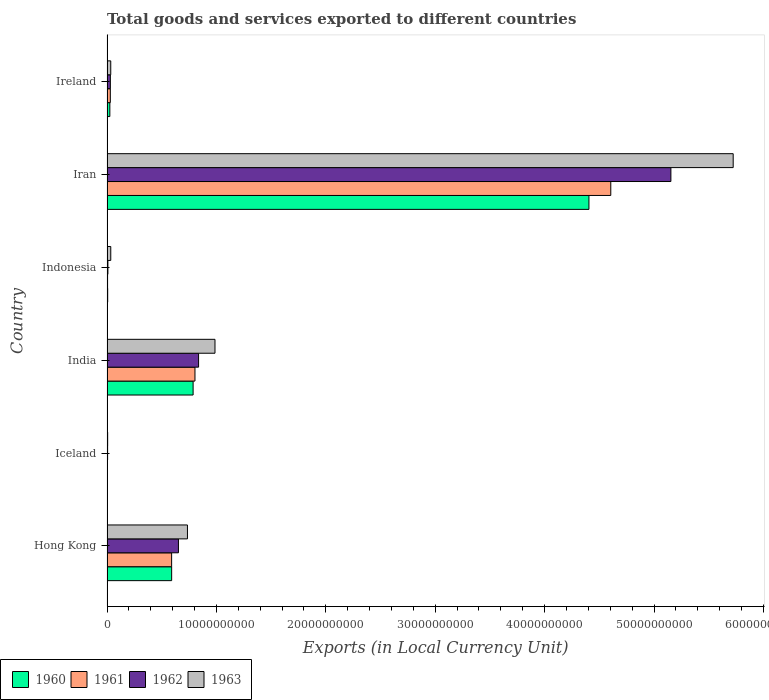How many different coloured bars are there?
Provide a short and direct response. 4. How many groups of bars are there?
Provide a short and direct response. 6. Are the number of bars per tick equal to the number of legend labels?
Your response must be concise. Yes. How many bars are there on the 1st tick from the top?
Your response must be concise. 4. How many bars are there on the 5th tick from the bottom?
Ensure brevity in your answer.  4. In how many cases, is the number of bars for a given country not equal to the number of legend labels?
Your answer should be very brief. 0. What is the Amount of goods and services exports in 1961 in Indonesia?
Make the answer very short. 5.31e+07. Across all countries, what is the maximum Amount of goods and services exports in 1960?
Your answer should be very brief. 4.41e+1. Across all countries, what is the minimum Amount of goods and services exports in 1960?
Offer a very short reply. 3.71e+07. In which country was the Amount of goods and services exports in 1961 maximum?
Your answer should be compact. Iran. In which country was the Amount of goods and services exports in 1960 minimum?
Make the answer very short. Iceland. What is the total Amount of goods and services exports in 1963 in the graph?
Make the answer very short. 7.52e+1. What is the difference between the Amount of goods and services exports in 1961 in Hong Kong and that in Iceland?
Your answer should be compact. 5.87e+09. What is the difference between the Amount of goods and services exports in 1963 in Iceland and the Amount of goods and services exports in 1960 in Indonesia?
Ensure brevity in your answer.  -1.79e+06. What is the average Amount of goods and services exports in 1961 per country?
Make the answer very short. 1.01e+1. What is the difference between the Amount of goods and services exports in 1962 and Amount of goods and services exports in 1961 in India?
Provide a short and direct response. 3.30e+08. What is the ratio of the Amount of goods and services exports in 1963 in Hong Kong to that in Ireland?
Ensure brevity in your answer.  21.44. Is the Amount of goods and services exports in 1963 in Iceland less than that in Ireland?
Keep it short and to the point. Yes. Is the difference between the Amount of goods and services exports in 1962 in Iceland and Iran greater than the difference between the Amount of goods and services exports in 1961 in Iceland and Iran?
Keep it short and to the point. No. What is the difference between the highest and the second highest Amount of goods and services exports in 1962?
Make the answer very short. 4.32e+1. What is the difference between the highest and the lowest Amount of goods and services exports in 1962?
Provide a succinct answer. 5.15e+1. In how many countries, is the Amount of goods and services exports in 1961 greater than the average Amount of goods and services exports in 1961 taken over all countries?
Ensure brevity in your answer.  1. What does the 3rd bar from the top in Ireland represents?
Make the answer very short. 1961. What does the 1st bar from the bottom in Hong Kong represents?
Offer a very short reply. 1960. Is it the case that in every country, the sum of the Amount of goods and services exports in 1961 and Amount of goods and services exports in 1960 is greater than the Amount of goods and services exports in 1962?
Your answer should be compact. Yes. How many bars are there?
Ensure brevity in your answer.  24. Are all the bars in the graph horizontal?
Offer a terse response. Yes. How many countries are there in the graph?
Make the answer very short. 6. Does the graph contain any zero values?
Make the answer very short. No. How are the legend labels stacked?
Ensure brevity in your answer.  Horizontal. What is the title of the graph?
Ensure brevity in your answer.  Total goods and services exported to different countries. Does "2012" appear as one of the legend labels in the graph?
Make the answer very short. No. What is the label or title of the X-axis?
Provide a short and direct response. Exports (in Local Currency Unit). What is the label or title of the Y-axis?
Offer a very short reply. Country. What is the Exports (in Local Currency Unit) of 1960 in Hong Kong?
Ensure brevity in your answer.  5.91e+09. What is the Exports (in Local Currency Unit) in 1961 in Hong Kong?
Provide a short and direct response. 5.91e+09. What is the Exports (in Local Currency Unit) of 1962 in Hong Kong?
Offer a very short reply. 6.53e+09. What is the Exports (in Local Currency Unit) of 1963 in Hong Kong?
Your answer should be compact. 7.35e+09. What is the Exports (in Local Currency Unit) in 1960 in Iceland?
Your answer should be very brief. 3.71e+07. What is the Exports (in Local Currency Unit) of 1961 in Iceland?
Offer a terse response. 4.21e+07. What is the Exports (in Local Currency Unit) of 1962 in Iceland?
Offer a terse response. 5.52e+07. What is the Exports (in Local Currency Unit) in 1963 in Iceland?
Your response must be concise. 6.02e+07. What is the Exports (in Local Currency Unit) of 1960 in India?
Provide a succinct answer. 7.87e+09. What is the Exports (in Local Currency Unit) of 1961 in India?
Provide a short and direct response. 8.04e+09. What is the Exports (in Local Currency Unit) of 1962 in India?
Offer a terse response. 8.37e+09. What is the Exports (in Local Currency Unit) in 1963 in India?
Your answer should be compact. 9.87e+09. What is the Exports (in Local Currency Unit) in 1960 in Indonesia?
Give a very brief answer. 6.20e+07. What is the Exports (in Local Currency Unit) in 1961 in Indonesia?
Your response must be concise. 5.31e+07. What is the Exports (in Local Currency Unit) in 1962 in Indonesia?
Keep it short and to the point. 8.19e+07. What is the Exports (in Local Currency Unit) in 1963 in Indonesia?
Give a very brief answer. 3.44e+08. What is the Exports (in Local Currency Unit) in 1960 in Iran?
Keep it short and to the point. 4.41e+1. What is the Exports (in Local Currency Unit) in 1961 in Iran?
Make the answer very short. 4.60e+1. What is the Exports (in Local Currency Unit) of 1962 in Iran?
Offer a very short reply. 5.15e+1. What is the Exports (in Local Currency Unit) of 1963 in Iran?
Provide a succinct answer. 5.72e+1. What is the Exports (in Local Currency Unit) in 1960 in Ireland?
Ensure brevity in your answer.  2.60e+08. What is the Exports (in Local Currency Unit) of 1961 in Ireland?
Give a very brief answer. 3.04e+08. What is the Exports (in Local Currency Unit) of 1962 in Ireland?
Offer a terse response. 3.07e+08. What is the Exports (in Local Currency Unit) in 1963 in Ireland?
Ensure brevity in your answer.  3.43e+08. Across all countries, what is the maximum Exports (in Local Currency Unit) in 1960?
Make the answer very short. 4.41e+1. Across all countries, what is the maximum Exports (in Local Currency Unit) in 1961?
Offer a very short reply. 4.60e+1. Across all countries, what is the maximum Exports (in Local Currency Unit) in 1962?
Your response must be concise. 5.15e+1. Across all countries, what is the maximum Exports (in Local Currency Unit) of 1963?
Give a very brief answer. 5.72e+1. Across all countries, what is the minimum Exports (in Local Currency Unit) of 1960?
Ensure brevity in your answer.  3.71e+07. Across all countries, what is the minimum Exports (in Local Currency Unit) in 1961?
Offer a terse response. 4.21e+07. Across all countries, what is the minimum Exports (in Local Currency Unit) in 1962?
Your answer should be compact. 5.52e+07. Across all countries, what is the minimum Exports (in Local Currency Unit) in 1963?
Your answer should be compact. 6.02e+07. What is the total Exports (in Local Currency Unit) of 1960 in the graph?
Provide a succinct answer. 5.82e+1. What is the total Exports (in Local Currency Unit) of 1961 in the graph?
Your response must be concise. 6.04e+1. What is the total Exports (in Local Currency Unit) in 1962 in the graph?
Make the answer very short. 6.69e+1. What is the total Exports (in Local Currency Unit) in 1963 in the graph?
Offer a terse response. 7.52e+1. What is the difference between the Exports (in Local Currency Unit) of 1960 in Hong Kong and that in Iceland?
Your answer should be compact. 5.87e+09. What is the difference between the Exports (in Local Currency Unit) in 1961 in Hong Kong and that in Iceland?
Give a very brief answer. 5.87e+09. What is the difference between the Exports (in Local Currency Unit) of 1962 in Hong Kong and that in Iceland?
Offer a terse response. 6.47e+09. What is the difference between the Exports (in Local Currency Unit) in 1963 in Hong Kong and that in Iceland?
Offer a terse response. 7.29e+09. What is the difference between the Exports (in Local Currency Unit) of 1960 in Hong Kong and that in India?
Your response must be concise. -1.96e+09. What is the difference between the Exports (in Local Currency Unit) of 1961 in Hong Kong and that in India?
Ensure brevity in your answer.  -2.13e+09. What is the difference between the Exports (in Local Currency Unit) in 1962 in Hong Kong and that in India?
Offer a terse response. -1.84e+09. What is the difference between the Exports (in Local Currency Unit) in 1963 in Hong Kong and that in India?
Offer a terse response. -2.52e+09. What is the difference between the Exports (in Local Currency Unit) in 1960 in Hong Kong and that in Indonesia?
Your answer should be very brief. 5.85e+09. What is the difference between the Exports (in Local Currency Unit) in 1961 in Hong Kong and that in Indonesia?
Your answer should be very brief. 5.85e+09. What is the difference between the Exports (in Local Currency Unit) in 1962 in Hong Kong and that in Indonesia?
Keep it short and to the point. 6.45e+09. What is the difference between the Exports (in Local Currency Unit) in 1963 in Hong Kong and that in Indonesia?
Keep it short and to the point. 7.01e+09. What is the difference between the Exports (in Local Currency Unit) in 1960 in Hong Kong and that in Iran?
Your answer should be compact. -3.81e+1. What is the difference between the Exports (in Local Currency Unit) in 1961 in Hong Kong and that in Iran?
Offer a terse response. -4.01e+1. What is the difference between the Exports (in Local Currency Unit) of 1962 in Hong Kong and that in Iran?
Provide a succinct answer. -4.50e+1. What is the difference between the Exports (in Local Currency Unit) in 1963 in Hong Kong and that in Iran?
Your answer should be very brief. -4.99e+1. What is the difference between the Exports (in Local Currency Unit) in 1960 in Hong Kong and that in Ireland?
Provide a succinct answer. 5.65e+09. What is the difference between the Exports (in Local Currency Unit) in 1961 in Hong Kong and that in Ireland?
Offer a terse response. 5.60e+09. What is the difference between the Exports (in Local Currency Unit) of 1962 in Hong Kong and that in Ireland?
Your response must be concise. 6.22e+09. What is the difference between the Exports (in Local Currency Unit) of 1963 in Hong Kong and that in Ireland?
Your response must be concise. 7.01e+09. What is the difference between the Exports (in Local Currency Unit) in 1960 in Iceland and that in India?
Ensure brevity in your answer.  -7.83e+09. What is the difference between the Exports (in Local Currency Unit) of 1961 in Iceland and that in India?
Offer a very short reply. -8.00e+09. What is the difference between the Exports (in Local Currency Unit) in 1962 in Iceland and that in India?
Ensure brevity in your answer.  -8.31e+09. What is the difference between the Exports (in Local Currency Unit) in 1963 in Iceland and that in India?
Ensure brevity in your answer.  -9.81e+09. What is the difference between the Exports (in Local Currency Unit) in 1960 in Iceland and that in Indonesia?
Your answer should be very brief. -2.49e+07. What is the difference between the Exports (in Local Currency Unit) in 1961 in Iceland and that in Indonesia?
Ensure brevity in your answer.  -1.10e+07. What is the difference between the Exports (in Local Currency Unit) in 1962 in Iceland and that in Indonesia?
Provide a succinct answer. -2.67e+07. What is the difference between the Exports (in Local Currency Unit) in 1963 in Iceland and that in Indonesia?
Provide a succinct answer. -2.84e+08. What is the difference between the Exports (in Local Currency Unit) of 1960 in Iceland and that in Iran?
Give a very brief answer. -4.40e+1. What is the difference between the Exports (in Local Currency Unit) of 1961 in Iceland and that in Iran?
Keep it short and to the point. -4.60e+1. What is the difference between the Exports (in Local Currency Unit) in 1962 in Iceland and that in Iran?
Offer a terse response. -5.15e+1. What is the difference between the Exports (in Local Currency Unit) of 1963 in Iceland and that in Iran?
Offer a terse response. -5.72e+1. What is the difference between the Exports (in Local Currency Unit) in 1960 in Iceland and that in Ireland?
Give a very brief answer. -2.23e+08. What is the difference between the Exports (in Local Currency Unit) in 1961 in Iceland and that in Ireland?
Ensure brevity in your answer.  -2.62e+08. What is the difference between the Exports (in Local Currency Unit) in 1962 in Iceland and that in Ireland?
Give a very brief answer. -2.51e+08. What is the difference between the Exports (in Local Currency Unit) in 1963 in Iceland and that in Ireland?
Your answer should be compact. -2.83e+08. What is the difference between the Exports (in Local Currency Unit) of 1960 in India and that in Indonesia?
Provide a short and direct response. 7.81e+09. What is the difference between the Exports (in Local Currency Unit) in 1961 in India and that in Indonesia?
Provide a short and direct response. 7.99e+09. What is the difference between the Exports (in Local Currency Unit) in 1962 in India and that in Indonesia?
Your answer should be compact. 8.29e+09. What is the difference between the Exports (in Local Currency Unit) in 1963 in India and that in Indonesia?
Offer a very short reply. 9.53e+09. What is the difference between the Exports (in Local Currency Unit) of 1960 in India and that in Iran?
Keep it short and to the point. -3.62e+1. What is the difference between the Exports (in Local Currency Unit) in 1961 in India and that in Iran?
Ensure brevity in your answer.  -3.80e+1. What is the difference between the Exports (in Local Currency Unit) in 1962 in India and that in Iran?
Provide a short and direct response. -4.32e+1. What is the difference between the Exports (in Local Currency Unit) in 1963 in India and that in Iran?
Your response must be concise. -4.74e+1. What is the difference between the Exports (in Local Currency Unit) of 1960 in India and that in Ireland?
Ensure brevity in your answer.  7.61e+09. What is the difference between the Exports (in Local Currency Unit) of 1961 in India and that in Ireland?
Your response must be concise. 7.74e+09. What is the difference between the Exports (in Local Currency Unit) of 1962 in India and that in Ireland?
Ensure brevity in your answer.  8.06e+09. What is the difference between the Exports (in Local Currency Unit) of 1963 in India and that in Ireland?
Your answer should be very brief. 9.53e+09. What is the difference between the Exports (in Local Currency Unit) in 1960 in Indonesia and that in Iran?
Provide a succinct answer. -4.40e+1. What is the difference between the Exports (in Local Currency Unit) in 1961 in Indonesia and that in Iran?
Your answer should be very brief. -4.60e+1. What is the difference between the Exports (in Local Currency Unit) in 1962 in Indonesia and that in Iran?
Offer a terse response. -5.15e+1. What is the difference between the Exports (in Local Currency Unit) in 1963 in Indonesia and that in Iran?
Provide a short and direct response. -5.69e+1. What is the difference between the Exports (in Local Currency Unit) in 1960 in Indonesia and that in Ireland?
Your answer should be compact. -1.98e+08. What is the difference between the Exports (in Local Currency Unit) of 1961 in Indonesia and that in Ireland?
Offer a very short reply. -2.51e+08. What is the difference between the Exports (in Local Currency Unit) of 1962 in Indonesia and that in Ireland?
Offer a terse response. -2.25e+08. What is the difference between the Exports (in Local Currency Unit) in 1963 in Indonesia and that in Ireland?
Offer a terse response. 1.22e+06. What is the difference between the Exports (in Local Currency Unit) of 1960 in Iran and that in Ireland?
Your answer should be compact. 4.38e+1. What is the difference between the Exports (in Local Currency Unit) in 1961 in Iran and that in Ireland?
Keep it short and to the point. 4.57e+1. What is the difference between the Exports (in Local Currency Unit) in 1962 in Iran and that in Ireland?
Make the answer very short. 5.12e+1. What is the difference between the Exports (in Local Currency Unit) in 1963 in Iran and that in Ireland?
Offer a very short reply. 5.69e+1. What is the difference between the Exports (in Local Currency Unit) of 1960 in Hong Kong and the Exports (in Local Currency Unit) of 1961 in Iceland?
Provide a short and direct response. 5.87e+09. What is the difference between the Exports (in Local Currency Unit) in 1960 in Hong Kong and the Exports (in Local Currency Unit) in 1962 in Iceland?
Give a very brief answer. 5.85e+09. What is the difference between the Exports (in Local Currency Unit) in 1960 in Hong Kong and the Exports (in Local Currency Unit) in 1963 in Iceland?
Offer a terse response. 5.85e+09. What is the difference between the Exports (in Local Currency Unit) of 1961 in Hong Kong and the Exports (in Local Currency Unit) of 1962 in Iceland?
Provide a succinct answer. 5.85e+09. What is the difference between the Exports (in Local Currency Unit) of 1961 in Hong Kong and the Exports (in Local Currency Unit) of 1963 in Iceland?
Your answer should be very brief. 5.85e+09. What is the difference between the Exports (in Local Currency Unit) of 1962 in Hong Kong and the Exports (in Local Currency Unit) of 1963 in Iceland?
Your response must be concise. 6.47e+09. What is the difference between the Exports (in Local Currency Unit) of 1960 in Hong Kong and the Exports (in Local Currency Unit) of 1961 in India?
Your answer should be compact. -2.13e+09. What is the difference between the Exports (in Local Currency Unit) in 1960 in Hong Kong and the Exports (in Local Currency Unit) in 1962 in India?
Offer a very short reply. -2.46e+09. What is the difference between the Exports (in Local Currency Unit) in 1960 in Hong Kong and the Exports (in Local Currency Unit) in 1963 in India?
Your answer should be very brief. -3.96e+09. What is the difference between the Exports (in Local Currency Unit) of 1961 in Hong Kong and the Exports (in Local Currency Unit) of 1962 in India?
Offer a terse response. -2.46e+09. What is the difference between the Exports (in Local Currency Unit) in 1961 in Hong Kong and the Exports (in Local Currency Unit) in 1963 in India?
Provide a succinct answer. -3.96e+09. What is the difference between the Exports (in Local Currency Unit) of 1962 in Hong Kong and the Exports (in Local Currency Unit) of 1963 in India?
Provide a succinct answer. -3.34e+09. What is the difference between the Exports (in Local Currency Unit) in 1960 in Hong Kong and the Exports (in Local Currency Unit) in 1961 in Indonesia?
Offer a terse response. 5.86e+09. What is the difference between the Exports (in Local Currency Unit) in 1960 in Hong Kong and the Exports (in Local Currency Unit) in 1962 in Indonesia?
Offer a terse response. 5.83e+09. What is the difference between the Exports (in Local Currency Unit) in 1960 in Hong Kong and the Exports (in Local Currency Unit) in 1963 in Indonesia?
Your answer should be very brief. 5.57e+09. What is the difference between the Exports (in Local Currency Unit) of 1961 in Hong Kong and the Exports (in Local Currency Unit) of 1962 in Indonesia?
Offer a very short reply. 5.83e+09. What is the difference between the Exports (in Local Currency Unit) in 1961 in Hong Kong and the Exports (in Local Currency Unit) in 1963 in Indonesia?
Provide a succinct answer. 5.56e+09. What is the difference between the Exports (in Local Currency Unit) of 1962 in Hong Kong and the Exports (in Local Currency Unit) of 1963 in Indonesia?
Give a very brief answer. 6.19e+09. What is the difference between the Exports (in Local Currency Unit) of 1960 in Hong Kong and the Exports (in Local Currency Unit) of 1961 in Iran?
Your answer should be compact. -4.01e+1. What is the difference between the Exports (in Local Currency Unit) of 1960 in Hong Kong and the Exports (in Local Currency Unit) of 1962 in Iran?
Your answer should be very brief. -4.56e+1. What is the difference between the Exports (in Local Currency Unit) of 1960 in Hong Kong and the Exports (in Local Currency Unit) of 1963 in Iran?
Make the answer very short. -5.13e+1. What is the difference between the Exports (in Local Currency Unit) of 1961 in Hong Kong and the Exports (in Local Currency Unit) of 1962 in Iran?
Provide a succinct answer. -4.56e+1. What is the difference between the Exports (in Local Currency Unit) of 1961 in Hong Kong and the Exports (in Local Currency Unit) of 1963 in Iran?
Your response must be concise. -5.13e+1. What is the difference between the Exports (in Local Currency Unit) in 1962 in Hong Kong and the Exports (in Local Currency Unit) in 1963 in Iran?
Offer a terse response. -5.07e+1. What is the difference between the Exports (in Local Currency Unit) in 1960 in Hong Kong and the Exports (in Local Currency Unit) in 1961 in Ireland?
Give a very brief answer. 5.61e+09. What is the difference between the Exports (in Local Currency Unit) in 1960 in Hong Kong and the Exports (in Local Currency Unit) in 1962 in Ireland?
Provide a succinct answer. 5.60e+09. What is the difference between the Exports (in Local Currency Unit) in 1960 in Hong Kong and the Exports (in Local Currency Unit) in 1963 in Ireland?
Keep it short and to the point. 5.57e+09. What is the difference between the Exports (in Local Currency Unit) in 1961 in Hong Kong and the Exports (in Local Currency Unit) in 1962 in Ireland?
Provide a short and direct response. 5.60e+09. What is the difference between the Exports (in Local Currency Unit) in 1961 in Hong Kong and the Exports (in Local Currency Unit) in 1963 in Ireland?
Provide a succinct answer. 5.56e+09. What is the difference between the Exports (in Local Currency Unit) in 1962 in Hong Kong and the Exports (in Local Currency Unit) in 1963 in Ireland?
Offer a terse response. 6.19e+09. What is the difference between the Exports (in Local Currency Unit) in 1960 in Iceland and the Exports (in Local Currency Unit) in 1961 in India?
Give a very brief answer. -8.00e+09. What is the difference between the Exports (in Local Currency Unit) of 1960 in Iceland and the Exports (in Local Currency Unit) of 1962 in India?
Provide a succinct answer. -8.33e+09. What is the difference between the Exports (in Local Currency Unit) of 1960 in Iceland and the Exports (in Local Currency Unit) of 1963 in India?
Give a very brief answer. -9.83e+09. What is the difference between the Exports (in Local Currency Unit) in 1961 in Iceland and the Exports (in Local Currency Unit) in 1962 in India?
Keep it short and to the point. -8.33e+09. What is the difference between the Exports (in Local Currency Unit) of 1961 in Iceland and the Exports (in Local Currency Unit) of 1963 in India?
Provide a succinct answer. -9.83e+09. What is the difference between the Exports (in Local Currency Unit) of 1962 in Iceland and the Exports (in Local Currency Unit) of 1963 in India?
Give a very brief answer. -9.81e+09. What is the difference between the Exports (in Local Currency Unit) in 1960 in Iceland and the Exports (in Local Currency Unit) in 1961 in Indonesia?
Your answer should be very brief. -1.60e+07. What is the difference between the Exports (in Local Currency Unit) of 1960 in Iceland and the Exports (in Local Currency Unit) of 1962 in Indonesia?
Provide a succinct answer. -4.48e+07. What is the difference between the Exports (in Local Currency Unit) in 1960 in Iceland and the Exports (in Local Currency Unit) in 1963 in Indonesia?
Your answer should be compact. -3.07e+08. What is the difference between the Exports (in Local Currency Unit) of 1961 in Iceland and the Exports (in Local Currency Unit) of 1962 in Indonesia?
Your response must be concise. -3.98e+07. What is the difference between the Exports (in Local Currency Unit) of 1961 in Iceland and the Exports (in Local Currency Unit) of 1963 in Indonesia?
Your answer should be very brief. -3.02e+08. What is the difference between the Exports (in Local Currency Unit) in 1962 in Iceland and the Exports (in Local Currency Unit) in 1963 in Indonesia?
Your answer should be very brief. -2.89e+08. What is the difference between the Exports (in Local Currency Unit) in 1960 in Iceland and the Exports (in Local Currency Unit) in 1961 in Iran?
Provide a succinct answer. -4.60e+1. What is the difference between the Exports (in Local Currency Unit) in 1960 in Iceland and the Exports (in Local Currency Unit) in 1962 in Iran?
Ensure brevity in your answer.  -5.15e+1. What is the difference between the Exports (in Local Currency Unit) of 1960 in Iceland and the Exports (in Local Currency Unit) of 1963 in Iran?
Offer a terse response. -5.72e+1. What is the difference between the Exports (in Local Currency Unit) of 1961 in Iceland and the Exports (in Local Currency Unit) of 1962 in Iran?
Offer a very short reply. -5.15e+1. What is the difference between the Exports (in Local Currency Unit) in 1961 in Iceland and the Exports (in Local Currency Unit) in 1963 in Iran?
Offer a terse response. -5.72e+1. What is the difference between the Exports (in Local Currency Unit) in 1962 in Iceland and the Exports (in Local Currency Unit) in 1963 in Iran?
Offer a terse response. -5.72e+1. What is the difference between the Exports (in Local Currency Unit) of 1960 in Iceland and the Exports (in Local Currency Unit) of 1961 in Ireland?
Provide a short and direct response. -2.67e+08. What is the difference between the Exports (in Local Currency Unit) in 1960 in Iceland and the Exports (in Local Currency Unit) in 1962 in Ireland?
Offer a very short reply. -2.69e+08. What is the difference between the Exports (in Local Currency Unit) in 1960 in Iceland and the Exports (in Local Currency Unit) in 1963 in Ireland?
Ensure brevity in your answer.  -3.06e+08. What is the difference between the Exports (in Local Currency Unit) of 1961 in Iceland and the Exports (in Local Currency Unit) of 1962 in Ireland?
Offer a terse response. -2.64e+08. What is the difference between the Exports (in Local Currency Unit) in 1961 in Iceland and the Exports (in Local Currency Unit) in 1963 in Ireland?
Provide a succinct answer. -3.01e+08. What is the difference between the Exports (in Local Currency Unit) of 1962 in Iceland and the Exports (in Local Currency Unit) of 1963 in Ireland?
Your answer should be very brief. -2.88e+08. What is the difference between the Exports (in Local Currency Unit) in 1960 in India and the Exports (in Local Currency Unit) in 1961 in Indonesia?
Offer a terse response. 7.82e+09. What is the difference between the Exports (in Local Currency Unit) in 1960 in India and the Exports (in Local Currency Unit) in 1962 in Indonesia?
Offer a terse response. 7.79e+09. What is the difference between the Exports (in Local Currency Unit) in 1960 in India and the Exports (in Local Currency Unit) in 1963 in Indonesia?
Offer a terse response. 7.53e+09. What is the difference between the Exports (in Local Currency Unit) in 1961 in India and the Exports (in Local Currency Unit) in 1962 in Indonesia?
Keep it short and to the point. 7.96e+09. What is the difference between the Exports (in Local Currency Unit) in 1961 in India and the Exports (in Local Currency Unit) in 1963 in Indonesia?
Your response must be concise. 7.70e+09. What is the difference between the Exports (in Local Currency Unit) in 1962 in India and the Exports (in Local Currency Unit) in 1963 in Indonesia?
Provide a short and direct response. 8.03e+09. What is the difference between the Exports (in Local Currency Unit) of 1960 in India and the Exports (in Local Currency Unit) of 1961 in Iran?
Make the answer very short. -3.82e+1. What is the difference between the Exports (in Local Currency Unit) of 1960 in India and the Exports (in Local Currency Unit) of 1962 in Iran?
Ensure brevity in your answer.  -4.37e+1. What is the difference between the Exports (in Local Currency Unit) of 1960 in India and the Exports (in Local Currency Unit) of 1963 in Iran?
Provide a short and direct response. -4.94e+1. What is the difference between the Exports (in Local Currency Unit) of 1961 in India and the Exports (in Local Currency Unit) of 1962 in Iran?
Your answer should be compact. -4.35e+1. What is the difference between the Exports (in Local Currency Unit) in 1961 in India and the Exports (in Local Currency Unit) in 1963 in Iran?
Give a very brief answer. -4.92e+1. What is the difference between the Exports (in Local Currency Unit) of 1962 in India and the Exports (in Local Currency Unit) of 1963 in Iran?
Offer a terse response. -4.89e+1. What is the difference between the Exports (in Local Currency Unit) in 1960 in India and the Exports (in Local Currency Unit) in 1961 in Ireland?
Keep it short and to the point. 7.57e+09. What is the difference between the Exports (in Local Currency Unit) of 1960 in India and the Exports (in Local Currency Unit) of 1962 in Ireland?
Keep it short and to the point. 7.56e+09. What is the difference between the Exports (in Local Currency Unit) of 1960 in India and the Exports (in Local Currency Unit) of 1963 in Ireland?
Give a very brief answer. 7.53e+09. What is the difference between the Exports (in Local Currency Unit) of 1961 in India and the Exports (in Local Currency Unit) of 1962 in Ireland?
Provide a succinct answer. 7.73e+09. What is the difference between the Exports (in Local Currency Unit) in 1961 in India and the Exports (in Local Currency Unit) in 1963 in Ireland?
Your answer should be compact. 7.70e+09. What is the difference between the Exports (in Local Currency Unit) of 1962 in India and the Exports (in Local Currency Unit) of 1963 in Ireland?
Provide a short and direct response. 8.03e+09. What is the difference between the Exports (in Local Currency Unit) in 1960 in Indonesia and the Exports (in Local Currency Unit) in 1961 in Iran?
Offer a very short reply. -4.60e+1. What is the difference between the Exports (in Local Currency Unit) of 1960 in Indonesia and the Exports (in Local Currency Unit) of 1962 in Iran?
Make the answer very short. -5.15e+1. What is the difference between the Exports (in Local Currency Unit) of 1960 in Indonesia and the Exports (in Local Currency Unit) of 1963 in Iran?
Your response must be concise. -5.72e+1. What is the difference between the Exports (in Local Currency Unit) in 1961 in Indonesia and the Exports (in Local Currency Unit) in 1962 in Iran?
Give a very brief answer. -5.15e+1. What is the difference between the Exports (in Local Currency Unit) in 1961 in Indonesia and the Exports (in Local Currency Unit) in 1963 in Iran?
Your answer should be compact. -5.72e+1. What is the difference between the Exports (in Local Currency Unit) in 1962 in Indonesia and the Exports (in Local Currency Unit) in 1963 in Iran?
Your response must be concise. -5.72e+1. What is the difference between the Exports (in Local Currency Unit) in 1960 in Indonesia and the Exports (in Local Currency Unit) in 1961 in Ireland?
Your answer should be compact. -2.42e+08. What is the difference between the Exports (in Local Currency Unit) of 1960 in Indonesia and the Exports (in Local Currency Unit) of 1962 in Ireland?
Make the answer very short. -2.45e+08. What is the difference between the Exports (in Local Currency Unit) of 1960 in Indonesia and the Exports (in Local Currency Unit) of 1963 in Ireland?
Your response must be concise. -2.81e+08. What is the difference between the Exports (in Local Currency Unit) in 1961 in Indonesia and the Exports (in Local Currency Unit) in 1962 in Ireland?
Provide a short and direct response. -2.53e+08. What is the difference between the Exports (in Local Currency Unit) of 1961 in Indonesia and the Exports (in Local Currency Unit) of 1963 in Ireland?
Make the answer very short. -2.90e+08. What is the difference between the Exports (in Local Currency Unit) of 1962 in Indonesia and the Exports (in Local Currency Unit) of 1963 in Ireland?
Keep it short and to the point. -2.61e+08. What is the difference between the Exports (in Local Currency Unit) in 1960 in Iran and the Exports (in Local Currency Unit) in 1961 in Ireland?
Your response must be concise. 4.37e+1. What is the difference between the Exports (in Local Currency Unit) of 1960 in Iran and the Exports (in Local Currency Unit) of 1962 in Ireland?
Offer a very short reply. 4.37e+1. What is the difference between the Exports (in Local Currency Unit) in 1960 in Iran and the Exports (in Local Currency Unit) in 1963 in Ireland?
Make the answer very short. 4.37e+1. What is the difference between the Exports (in Local Currency Unit) in 1961 in Iran and the Exports (in Local Currency Unit) in 1962 in Ireland?
Offer a very short reply. 4.57e+1. What is the difference between the Exports (in Local Currency Unit) in 1961 in Iran and the Exports (in Local Currency Unit) in 1963 in Ireland?
Keep it short and to the point. 4.57e+1. What is the difference between the Exports (in Local Currency Unit) of 1962 in Iran and the Exports (in Local Currency Unit) of 1963 in Ireland?
Offer a very short reply. 5.12e+1. What is the average Exports (in Local Currency Unit) in 1960 per country?
Offer a terse response. 9.70e+09. What is the average Exports (in Local Currency Unit) of 1961 per country?
Provide a succinct answer. 1.01e+1. What is the average Exports (in Local Currency Unit) of 1962 per country?
Ensure brevity in your answer.  1.11e+1. What is the average Exports (in Local Currency Unit) in 1963 per country?
Provide a succinct answer. 1.25e+1. What is the difference between the Exports (in Local Currency Unit) in 1960 and Exports (in Local Currency Unit) in 1961 in Hong Kong?
Offer a very short reply. 2.67e+06. What is the difference between the Exports (in Local Currency Unit) in 1960 and Exports (in Local Currency Unit) in 1962 in Hong Kong?
Your response must be concise. -6.20e+08. What is the difference between the Exports (in Local Currency Unit) of 1960 and Exports (in Local Currency Unit) of 1963 in Hong Kong?
Your response must be concise. -1.44e+09. What is the difference between the Exports (in Local Currency Unit) in 1961 and Exports (in Local Currency Unit) in 1962 in Hong Kong?
Offer a terse response. -6.23e+08. What is the difference between the Exports (in Local Currency Unit) of 1961 and Exports (in Local Currency Unit) of 1963 in Hong Kong?
Your answer should be compact. -1.45e+09. What is the difference between the Exports (in Local Currency Unit) of 1962 and Exports (in Local Currency Unit) of 1963 in Hong Kong?
Give a very brief answer. -8.24e+08. What is the difference between the Exports (in Local Currency Unit) of 1960 and Exports (in Local Currency Unit) of 1961 in Iceland?
Offer a terse response. -5.02e+06. What is the difference between the Exports (in Local Currency Unit) of 1960 and Exports (in Local Currency Unit) of 1962 in Iceland?
Keep it short and to the point. -1.81e+07. What is the difference between the Exports (in Local Currency Unit) of 1960 and Exports (in Local Currency Unit) of 1963 in Iceland?
Offer a terse response. -2.31e+07. What is the difference between the Exports (in Local Currency Unit) of 1961 and Exports (in Local Currency Unit) of 1962 in Iceland?
Make the answer very short. -1.30e+07. What is the difference between the Exports (in Local Currency Unit) of 1961 and Exports (in Local Currency Unit) of 1963 in Iceland?
Provide a succinct answer. -1.81e+07. What is the difference between the Exports (in Local Currency Unit) in 1962 and Exports (in Local Currency Unit) in 1963 in Iceland?
Provide a succinct answer. -5.02e+06. What is the difference between the Exports (in Local Currency Unit) in 1960 and Exports (in Local Currency Unit) in 1961 in India?
Give a very brief answer. -1.70e+08. What is the difference between the Exports (in Local Currency Unit) of 1960 and Exports (in Local Currency Unit) of 1962 in India?
Give a very brief answer. -5.00e+08. What is the difference between the Exports (in Local Currency Unit) in 1960 and Exports (in Local Currency Unit) in 1963 in India?
Ensure brevity in your answer.  -2.00e+09. What is the difference between the Exports (in Local Currency Unit) in 1961 and Exports (in Local Currency Unit) in 1962 in India?
Offer a very short reply. -3.30e+08. What is the difference between the Exports (in Local Currency Unit) of 1961 and Exports (in Local Currency Unit) of 1963 in India?
Offer a very short reply. -1.83e+09. What is the difference between the Exports (in Local Currency Unit) of 1962 and Exports (in Local Currency Unit) of 1963 in India?
Your answer should be very brief. -1.50e+09. What is the difference between the Exports (in Local Currency Unit) in 1960 and Exports (in Local Currency Unit) in 1961 in Indonesia?
Your answer should be compact. 8.85e+06. What is the difference between the Exports (in Local Currency Unit) in 1960 and Exports (in Local Currency Unit) in 1962 in Indonesia?
Offer a terse response. -1.99e+07. What is the difference between the Exports (in Local Currency Unit) in 1960 and Exports (in Local Currency Unit) in 1963 in Indonesia?
Your answer should be very brief. -2.82e+08. What is the difference between the Exports (in Local Currency Unit) of 1961 and Exports (in Local Currency Unit) of 1962 in Indonesia?
Your answer should be compact. -2.88e+07. What is the difference between the Exports (in Local Currency Unit) of 1961 and Exports (in Local Currency Unit) of 1963 in Indonesia?
Provide a short and direct response. -2.91e+08. What is the difference between the Exports (in Local Currency Unit) in 1962 and Exports (in Local Currency Unit) in 1963 in Indonesia?
Ensure brevity in your answer.  -2.62e+08. What is the difference between the Exports (in Local Currency Unit) of 1960 and Exports (in Local Currency Unit) of 1961 in Iran?
Provide a succinct answer. -2.00e+09. What is the difference between the Exports (in Local Currency Unit) in 1960 and Exports (in Local Currency Unit) in 1962 in Iran?
Your response must be concise. -7.49e+09. What is the difference between the Exports (in Local Currency Unit) in 1960 and Exports (in Local Currency Unit) in 1963 in Iran?
Ensure brevity in your answer.  -1.32e+1. What is the difference between the Exports (in Local Currency Unit) of 1961 and Exports (in Local Currency Unit) of 1962 in Iran?
Ensure brevity in your answer.  -5.49e+09. What is the difference between the Exports (in Local Currency Unit) in 1961 and Exports (in Local Currency Unit) in 1963 in Iran?
Give a very brief answer. -1.12e+1. What is the difference between the Exports (in Local Currency Unit) in 1962 and Exports (in Local Currency Unit) in 1963 in Iran?
Your response must be concise. -5.69e+09. What is the difference between the Exports (in Local Currency Unit) in 1960 and Exports (in Local Currency Unit) in 1961 in Ireland?
Offer a very short reply. -4.43e+07. What is the difference between the Exports (in Local Currency Unit) in 1960 and Exports (in Local Currency Unit) in 1962 in Ireland?
Offer a very short reply. -4.69e+07. What is the difference between the Exports (in Local Currency Unit) of 1960 and Exports (in Local Currency Unit) of 1963 in Ireland?
Your response must be concise. -8.33e+07. What is the difference between the Exports (in Local Currency Unit) in 1961 and Exports (in Local Currency Unit) in 1962 in Ireland?
Keep it short and to the point. -2.58e+06. What is the difference between the Exports (in Local Currency Unit) of 1961 and Exports (in Local Currency Unit) of 1963 in Ireland?
Your answer should be very brief. -3.90e+07. What is the difference between the Exports (in Local Currency Unit) of 1962 and Exports (in Local Currency Unit) of 1963 in Ireland?
Keep it short and to the point. -3.64e+07. What is the ratio of the Exports (in Local Currency Unit) in 1960 in Hong Kong to that in Iceland?
Your response must be concise. 159.23. What is the ratio of the Exports (in Local Currency Unit) in 1961 in Hong Kong to that in Iceland?
Ensure brevity in your answer.  140.21. What is the ratio of the Exports (in Local Currency Unit) of 1962 in Hong Kong to that in Iceland?
Offer a terse response. 118.35. What is the ratio of the Exports (in Local Currency Unit) in 1963 in Hong Kong to that in Iceland?
Your answer should be compact. 122.18. What is the ratio of the Exports (in Local Currency Unit) in 1960 in Hong Kong to that in India?
Your response must be concise. 0.75. What is the ratio of the Exports (in Local Currency Unit) of 1961 in Hong Kong to that in India?
Make the answer very short. 0.73. What is the ratio of the Exports (in Local Currency Unit) of 1962 in Hong Kong to that in India?
Provide a succinct answer. 0.78. What is the ratio of the Exports (in Local Currency Unit) in 1963 in Hong Kong to that in India?
Your answer should be compact. 0.75. What is the ratio of the Exports (in Local Currency Unit) in 1960 in Hong Kong to that in Indonesia?
Your answer should be compact. 95.35. What is the ratio of the Exports (in Local Currency Unit) in 1961 in Hong Kong to that in Indonesia?
Offer a terse response. 111.19. What is the ratio of the Exports (in Local Currency Unit) of 1962 in Hong Kong to that in Indonesia?
Provide a succinct answer. 79.73. What is the ratio of the Exports (in Local Currency Unit) in 1963 in Hong Kong to that in Indonesia?
Offer a terse response. 21.36. What is the ratio of the Exports (in Local Currency Unit) in 1960 in Hong Kong to that in Iran?
Give a very brief answer. 0.13. What is the ratio of the Exports (in Local Currency Unit) of 1961 in Hong Kong to that in Iran?
Keep it short and to the point. 0.13. What is the ratio of the Exports (in Local Currency Unit) of 1962 in Hong Kong to that in Iran?
Offer a very short reply. 0.13. What is the ratio of the Exports (in Local Currency Unit) of 1963 in Hong Kong to that in Iran?
Your answer should be very brief. 0.13. What is the ratio of the Exports (in Local Currency Unit) in 1960 in Hong Kong to that in Ireland?
Ensure brevity in your answer.  22.76. What is the ratio of the Exports (in Local Currency Unit) in 1961 in Hong Kong to that in Ireland?
Offer a very short reply. 19.43. What is the ratio of the Exports (in Local Currency Unit) in 1962 in Hong Kong to that in Ireland?
Provide a short and direct response. 21.3. What is the ratio of the Exports (in Local Currency Unit) of 1963 in Hong Kong to that in Ireland?
Provide a succinct answer. 21.44. What is the ratio of the Exports (in Local Currency Unit) of 1960 in Iceland to that in India?
Provide a short and direct response. 0. What is the ratio of the Exports (in Local Currency Unit) in 1961 in Iceland to that in India?
Make the answer very short. 0.01. What is the ratio of the Exports (in Local Currency Unit) of 1962 in Iceland to that in India?
Keep it short and to the point. 0.01. What is the ratio of the Exports (in Local Currency Unit) of 1963 in Iceland to that in India?
Give a very brief answer. 0.01. What is the ratio of the Exports (in Local Currency Unit) in 1960 in Iceland to that in Indonesia?
Provide a succinct answer. 0.6. What is the ratio of the Exports (in Local Currency Unit) in 1961 in Iceland to that in Indonesia?
Keep it short and to the point. 0.79. What is the ratio of the Exports (in Local Currency Unit) in 1962 in Iceland to that in Indonesia?
Your answer should be very brief. 0.67. What is the ratio of the Exports (in Local Currency Unit) in 1963 in Iceland to that in Indonesia?
Provide a short and direct response. 0.17. What is the ratio of the Exports (in Local Currency Unit) of 1960 in Iceland to that in Iran?
Keep it short and to the point. 0. What is the ratio of the Exports (in Local Currency Unit) in 1961 in Iceland to that in Iran?
Make the answer very short. 0. What is the ratio of the Exports (in Local Currency Unit) of 1962 in Iceland to that in Iran?
Give a very brief answer. 0. What is the ratio of the Exports (in Local Currency Unit) in 1963 in Iceland to that in Iran?
Provide a short and direct response. 0. What is the ratio of the Exports (in Local Currency Unit) of 1960 in Iceland to that in Ireland?
Provide a succinct answer. 0.14. What is the ratio of the Exports (in Local Currency Unit) in 1961 in Iceland to that in Ireland?
Ensure brevity in your answer.  0.14. What is the ratio of the Exports (in Local Currency Unit) in 1962 in Iceland to that in Ireland?
Keep it short and to the point. 0.18. What is the ratio of the Exports (in Local Currency Unit) in 1963 in Iceland to that in Ireland?
Give a very brief answer. 0.18. What is the ratio of the Exports (in Local Currency Unit) in 1960 in India to that in Indonesia?
Keep it short and to the point. 126.97. What is the ratio of the Exports (in Local Currency Unit) in 1961 in India to that in Indonesia?
Provide a succinct answer. 151.34. What is the ratio of the Exports (in Local Currency Unit) in 1962 in India to that in Indonesia?
Give a very brief answer. 102.19. What is the ratio of the Exports (in Local Currency Unit) in 1963 in India to that in Indonesia?
Your answer should be very brief. 28.67. What is the ratio of the Exports (in Local Currency Unit) of 1960 in India to that in Iran?
Your answer should be compact. 0.18. What is the ratio of the Exports (in Local Currency Unit) in 1961 in India to that in Iran?
Make the answer very short. 0.17. What is the ratio of the Exports (in Local Currency Unit) in 1962 in India to that in Iran?
Ensure brevity in your answer.  0.16. What is the ratio of the Exports (in Local Currency Unit) of 1963 in India to that in Iran?
Your response must be concise. 0.17. What is the ratio of the Exports (in Local Currency Unit) in 1960 in India to that in Ireland?
Your answer should be compact. 30.31. What is the ratio of the Exports (in Local Currency Unit) in 1961 in India to that in Ireland?
Ensure brevity in your answer.  26.45. What is the ratio of the Exports (in Local Currency Unit) of 1962 in India to that in Ireland?
Provide a short and direct response. 27.3. What is the ratio of the Exports (in Local Currency Unit) in 1963 in India to that in Ireland?
Provide a succinct answer. 28.78. What is the ratio of the Exports (in Local Currency Unit) in 1960 in Indonesia to that in Iran?
Ensure brevity in your answer.  0. What is the ratio of the Exports (in Local Currency Unit) in 1961 in Indonesia to that in Iran?
Provide a short and direct response. 0. What is the ratio of the Exports (in Local Currency Unit) in 1962 in Indonesia to that in Iran?
Ensure brevity in your answer.  0. What is the ratio of the Exports (in Local Currency Unit) in 1963 in Indonesia to that in Iran?
Provide a succinct answer. 0.01. What is the ratio of the Exports (in Local Currency Unit) in 1960 in Indonesia to that in Ireland?
Provide a short and direct response. 0.24. What is the ratio of the Exports (in Local Currency Unit) of 1961 in Indonesia to that in Ireland?
Give a very brief answer. 0.17. What is the ratio of the Exports (in Local Currency Unit) in 1962 in Indonesia to that in Ireland?
Your answer should be compact. 0.27. What is the ratio of the Exports (in Local Currency Unit) in 1960 in Iran to that in Ireland?
Provide a short and direct response. 169.64. What is the ratio of the Exports (in Local Currency Unit) of 1961 in Iran to that in Ireland?
Keep it short and to the point. 151.49. What is the ratio of the Exports (in Local Currency Unit) in 1962 in Iran to that in Ireland?
Ensure brevity in your answer.  168.13. What is the ratio of the Exports (in Local Currency Unit) in 1963 in Iran to that in Ireland?
Your response must be concise. 166.87. What is the difference between the highest and the second highest Exports (in Local Currency Unit) of 1960?
Offer a terse response. 3.62e+1. What is the difference between the highest and the second highest Exports (in Local Currency Unit) of 1961?
Offer a very short reply. 3.80e+1. What is the difference between the highest and the second highest Exports (in Local Currency Unit) in 1962?
Offer a terse response. 4.32e+1. What is the difference between the highest and the second highest Exports (in Local Currency Unit) of 1963?
Your answer should be very brief. 4.74e+1. What is the difference between the highest and the lowest Exports (in Local Currency Unit) of 1960?
Keep it short and to the point. 4.40e+1. What is the difference between the highest and the lowest Exports (in Local Currency Unit) of 1961?
Give a very brief answer. 4.60e+1. What is the difference between the highest and the lowest Exports (in Local Currency Unit) in 1962?
Offer a terse response. 5.15e+1. What is the difference between the highest and the lowest Exports (in Local Currency Unit) in 1963?
Keep it short and to the point. 5.72e+1. 